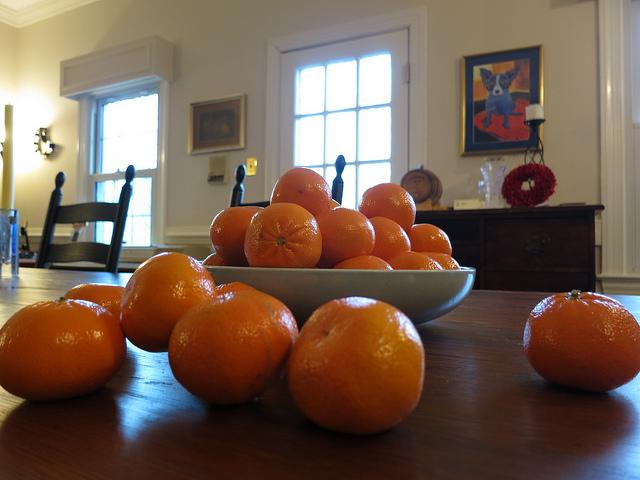Are the oranges real or fake?
Answer briefly. Real. How many oranges can be seen?
Be succinct. 17. What is covering the table?
Short answer required. Oranges. What kind of fruit is shown?
Write a very short answer. Orange. What is the portrait of?
Answer briefly. Dog. 